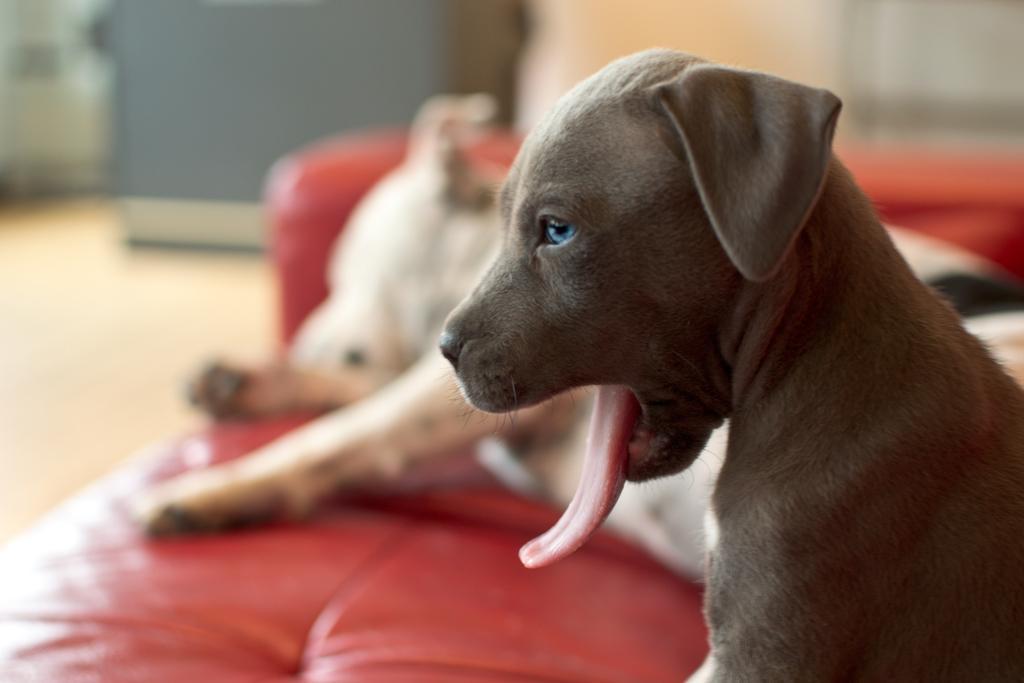In one or two sentences, can you explain what this image depicts? In this image we can see dogs, couch, and floor. There is a blur background. 